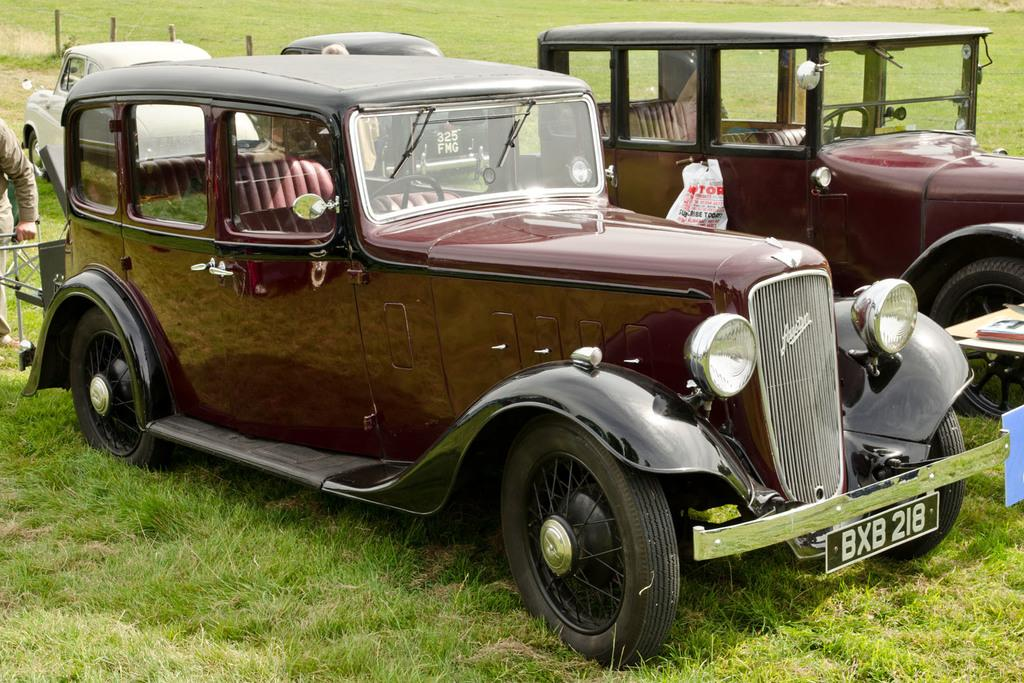What type of vehicles are in the image? There are antique cars in the image. Where are the antique cars located? The antique cars are on a grassland. Can you describe the person on the left side of the image? There is a man on the left side of the image. What type of clocks can be seen hanging from the trees in the image? There are no clocks visible in the image; it features antique cars on a grassland and a man on the left side. 